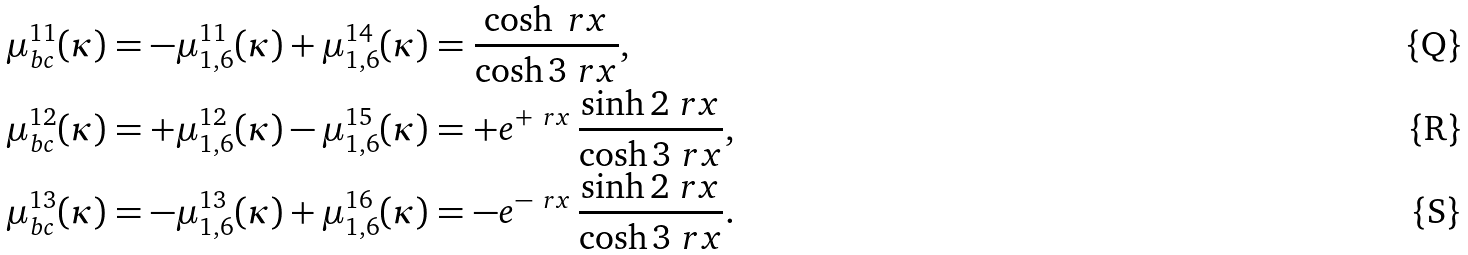<formula> <loc_0><loc_0><loc_500><loc_500>\mu _ { b c } ^ { 1 1 } ( \kappa ) & = - \mu ^ { 1 1 } _ { 1 , 6 } ( \kappa ) + \mu ^ { 1 4 } _ { 1 , 6 } ( \kappa ) = \frac { \cosh \ r x } { \cosh 3 \ r x } , \\ \mu _ { b c } ^ { 1 2 } ( \kappa ) & = + \mu ^ { 1 2 } _ { 1 , 6 } ( \kappa ) - \mu ^ { 1 5 } _ { 1 , 6 } ( \kappa ) = + e ^ { + \ r x } \, \frac { \sinh 2 \ r x } { \cosh 3 \ r x } , \\ \mu _ { b c } ^ { 1 3 } ( \kappa ) & = - \mu ^ { 1 3 } _ { 1 , 6 } ( \kappa ) + \mu ^ { 1 6 } _ { 1 , 6 } ( \kappa ) = - e ^ { - \ r x } \, \frac { \sinh 2 \ r x } { \cosh 3 \ r x } .</formula> 